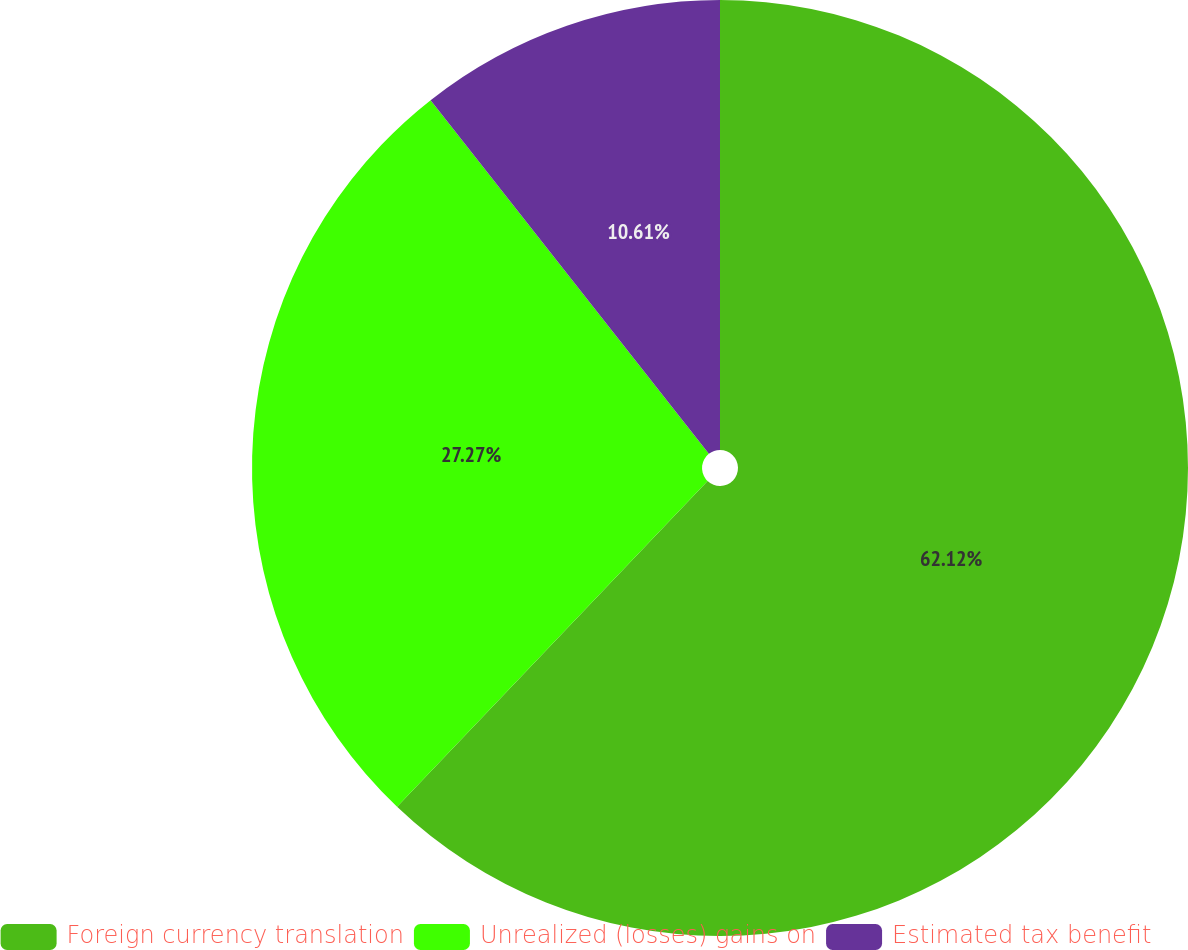<chart> <loc_0><loc_0><loc_500><loc_500><pie_chart><fcel>Foreign currency translation<fcel>Unrealized (losses) gains on<fcel>Estimated tax benefit<nl><fcel>62.12%<fcel>27.27%<fcel>10.61%<nl></chart> 